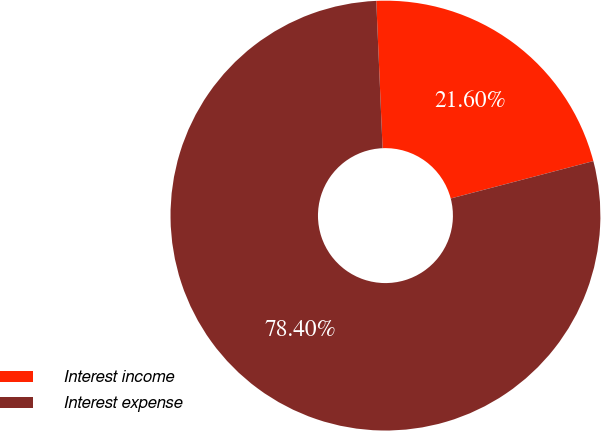Convert chart. <chart><loc_0><loc_0><loc_500><loc_500><pie_chart><fcel>Interest income<fcel>Interest expense<nl><fcel>21.6%<fcel>78.4%<nl></chart> 